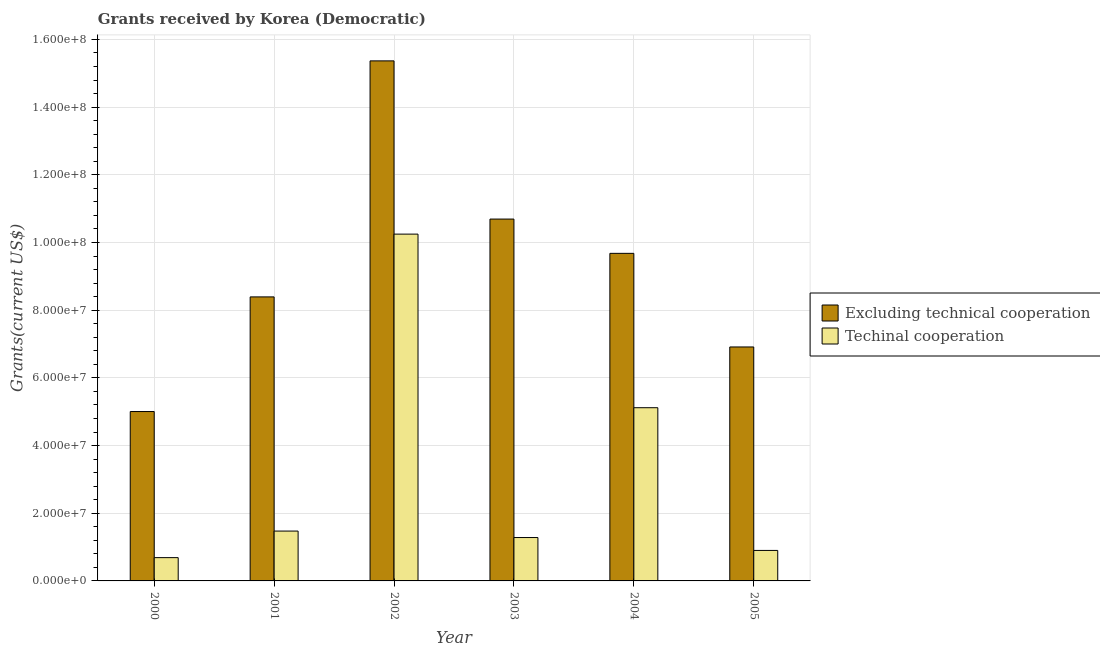Are the number of bars per tick equal to the number of legend labels?
Provide a short and direct response. Yes. Are the number of bars on each tick of the X-axis equal?
Provide a succinct answer. Yes. How many bars are there on the 3rd tick from the right?
Offer a very short reply. 2. What is the label of the 1st group of bars from the left?
Give a very brief answer. 2000. What is the amount of grants received(including technical cooperation) in 2001?
Offer a terse response. 1.47e+07. Across all years, what is the maximum amount of grants received(excluding technical cooperation)?
Your response must be concise. 1.54e+08. Across all years, what is the minimum amount of grants received(excluding technical cooperation)?
Give a very brief answer. 5.00e+07. In which year was the amount of grants received(including technical cooperation) minimum?
Keep it short and to the point. 2000. What is the total amount of grants received(excluding technical cooperation) in the graph?
Your answer should be compact. 5.60e+08. What is the difference between the amount of grants received(excluding technical cooperation) in 2004 and that in 2005?
Provide a short and direct response. 2.77e+07. What is the difference between the amount of grants received(including technical cooperation) in 2005 and the amount of grants received(excluding technical cooperation) in 2000?
Offer a terse response. 2.13e+06. What is the average amount of grants received(including technical cooperation) per year?
Provide a short and direct response. 3.28e+07. In the year 2001, what is the difference between the amount of grants received(excluding technical cooperation) and amount of grants received(including technical cooperation)?
Ensure brevity in your answer.  0. What is the ratio of the amount of grants received(including technical cooperation) in 2002 to that in 2003?
Make the answer very short. 7.99. Is the amount of grants received(including technical cooperation) in 2004 less than that in 2005?
Your answer should be very brief. No. What is the difference between the highest and the second highest amount of grants received(excluding technical cooperation)?
Your answer should be very brief. 4.67e+07. What is the difference between the highest and the lowest amount of grants received(excluding technical cooperation)?
Give a very brief answer. 1.04e+08. Is the sum of the amount of grants received(including technical cooperation) in 2000 and 2003 greater than the maximum amount of grants received(excluding technical cooperation) across all years?
Your answer should be compact. No. What does the 1st bar from the left in 2003 represents?
Provide a short and direct response. Excluding technical cooperation. What does the 2nd bar from the right in 2002 represents?
Offer a terse response. Excluding technical cooperation. How many bars are there?
Offer a terse response. 12. What is the difference between two consecutive major ticks on the Y-axis?
Your answer should be compact. 2.00e+07. Are the values on the major ticks of Y-axis written in scientific E-notation?
Offer a terse response. Yes. Does the graph contain grids?
Your answer should be very brief. Yes. Where does the legend appear in the graph?
Offer a terse response. Center right. How many legend labels are there?
Provide a succinct answer. 2. What is the title of the graph?
Make the answer very short. Grants received by Korea (Democratic). What is the label or title of the X-axis?
Make the answer very short. Year. What is the label or title of the Y-axis?
Give a very brief answer. Grants(current US$). What is the Grants(current US$) of Excluding technical cooperation in 2000?
Ensure brevity in your answer.  5.00e+07. What is the Grants(current US$) in Techinal cooperation in 2000?
Provide a short and direct response. 6.88e+06. What is the Grants(current US$) of Excluding technical cooperation in 2001?
Make the answer very short. 8.39e+07. What is the Grants(current US$) of Techinal cooperation in 2001?
Your answer should be very brief. 1.47e+07. What is the Grants(current US$) of Excluding technical cooperation in 2002?
Offer a terse response. 1.54e+08. What is the Grants(current US$) of Techinal cooperation in 2002?
Make the answer very short. 1.02e+08. What is the Grants(current US$) of Excluding technical cooperation in 2003?
Make the answer very short. 1.07e+08. What is the Grants(current US$) of Techinal cooperation in 2003?
Give a very brief answer. 1.28e+07. What is the Grants(current US$) of Excluding technical cooperation in 2004?
Your answer should be compact. 9.68e+07. What is the Grants(current US$) of Techinal cooperation in 2004?
Give a very brief answer. 5.12e+07. What is the Grants(current US$) in Excluding technical cooperation in 2005?
Your answer should be compact. 6.91e+07. What is the Grants(current US$) in Techinal cooperation in 2005?
Provide a short and direct response. 9.01e+06. Across all years, what is the maximum Grants(current US$) in Excluding technical cooperation?
Provide a succinct answer. 1.54e+08. Across all years, what is the maximum Grants(current US$) in Techinal cooperation?
Make the answer very short. 1.02e+08. Across all years, what is the minimum Grants(current US$) of Excluding technical cooperation?
Your answer should be very brief. 5.00e+07. Across all years, what is the minimum Grants(current US$) of Techinal cooperation?
Your response must be concise. 6.88e+06. What is the total Grants(current US$) of Excluding technical cooperation in the graph?
Offer a terse response. 5.60e+08. What is the total Grants(current US$) in Techinal cooperation in the graph?
Your response must be concise. 1.97e+08. What is the difference between the Grants(current US$) in Excluding technical cooperation in 2000 and that in 2001?
Ensure brevity in your answer.  -3.39e+07. What is the difference between the Grants(current US$) of Techinal cooperation in 2000 and that in 2001?
Your answer should be compact. -7.85e+06. What is the difference between the Grants(current US$) of Excluding technical cooperation in 2000 and that in 2002?
Ensure brevity in your answer.  -1.04e+08. What is the difference between the Grants(current US$) of Techinal cooperation in 2000 and that in 2002?
Ensure brevity in your answer.  -9.56e+07. What is the difference between the Grants(current US$) in Excluding technical cooperation in 2000 and that in 2003?
Your answer should be compact. -5.69e+07. What is the difference between the Grants(current US$) of Techinal cooperation in 2000 and that in 2003?
Provide a succinct answer. -5.94e+06. What is the difference between the Grants(current US$) of Excluding technical cooperation in 2000 and that in 2004?
Your answer should be compact. -4.67e+07. What is the difference between the Grants(current US$) in Techinal cooperation in 2000 and that in 2004?
Offer a very short reply. -4.43e+07. What is the difference between the Grants(current US$) in Excluding technical cooperation in 2000 and that in 2005?
Your response must be concise. -1.91e+07. What is the difference between the Grants(current US$) in Techinal cooperation in 2000 and that in 2005?
Ensure brevity in your answer.  -2.13e+06. What is the difference between the Grants(current US$) of Excluding technical cooperation in 2001 and that in 2002?
Make the answer very short. -6.97e+07. What is the difference between the Grants(current US$) in Techinal cooperation in 2001 and that in 2002?
Keep it short and to the point. -8.77e+07. What is the difference between the Grants(current US$) of Excluding technical cooperation in 2001 and that in 2003?
Give a very brief answer. -2.30e+07. What is the difference between the Grants(current US$) in Techinal cooperation in 2001 and that in 2003?
Make the answer very short. 1.91e+06. What is the difference between the Grants(current US$) of Excluding technical cooperation in 2001 and that in 2004?
Your answer should be very brief. -1.29e+07. What is the difference between the Grants(current US$) in Techinal cooperation in 2001 and that in 2004?
Give a very brief answer. -3.64e+07. What is the difference between the Grants(current US$) in Excluding technical cooperation in 2001 and that in 2005?
Your answer should be compact. 1.48e+07. What is the difference between the Grants(current US$) in Techinal cooperation in 2001 and that in 2005?
Ensure brevity in your answer.  5.72e+06. What is the difference between the Grants(current US$) of Excluding technical cooperation in 2002 and that in 2003?
Your answer should be very brief. 4.67e+07. What is the difference between the Grants(current US$) in Techinal cooperation in 2002 and that in 2003?
Offer a terse response. 8.96e+07. What is the difference between the Grants(current US$) of Excluding technical cooperation in 2002 and that in 2004?
Provide a short and direct response. 5.69e+07. What is the difference between the Grants(current US$) of Techinal cooperation in 2002 and that in 2004?
Make the answer very short. 5.13e+07. What is the difference between the Grants(current US$) of Excluding technical cooperation in 2002 and that in 2005?
Your answer should be compact. 8.45e+07. What is the difference between the Grants(current US$) of Techinal cooperation in 2002 and that in 2005?
Provide a succinct answer. 9.35e+07. What is the difference between the Grants(current US$) in Excluding technical cooperation in 2003 and that in 2004?
Offer a very short reply. 1.01e+07. What is the difference between the Grants(current US$) of Techinal cooperation in 2003 and that in 2004?
Give a very brief answer. -3.84e+07. What is the difference between the Grants(current US$) of Excluding technical cooperation in 2003 and that in 2005?
Keep it short and to the point. 3.78e+07. What is the difference between the Grants(current US$) of Techinal cooperation in 2003 and that in 2005?
Provide a short and direct response. 3.81e+06. What is the difference between the Grants(current US$) in Excluding technical cooperation in 2004 and that in 2005?
Ensure brevity in your answer.  2.77e+07. What is the difference between the Grants(current US$) of Techinal cooperation in 2004 and that in 2005?
Make the answer very short. 4.22e+07. What is the difference between the Grants(current US$) in Excluding technical cooperation in 2000 and the Grants(current US$) in Techinal cooperation in 2001?
Provide a succinct answer. 3.53e+07. What is the difference between the Grants(current US$) in Excluding technical cooperation in 2000 and the Grants(current US$) in Techinal cooperation in 2002?
Offer a very short reply. -5.24e+07. What is the difference between the Grants(current US$) of Excluding technical cooperation in 2000 and the Grants(current US$) of Techinal cooperation in 2003?
Your answer should be compact. 3.72e+07. What is the difference between the Grants(current US$) of Excluding technical cooperation in 2000 and the Grants(current US$) of Techinal cooperation in 2004?
Keep it short and to the point. -1.13e+06. What is the difference between the Grants(current US$) of Excluding technical cooperation in 2000 and the Grants(current US$) of Techinal cooperation in 2005?
Provide a short and direct response. 4.10e+07. What is the difference between the Grants(current US$) in Excluding technical cooperation in 2001 and the Grants(current US$) in Techinal cooperation in 2002?
Your answer should be very brief. -1.86e+07. What is the difference between the Grants(current US$) of Excluding technical cooperation in 2001 and the Grants(current US$) of Techinal cooperation in 2003?
Keep it short and to the point. 7.11e+07. What is the difference between the Grants(current US$) in Excluding technical cooperation in 2001 and the Grants(current US$) in Techinal cooperation in 2004?
Your answer should be very brief. 3.27e+07. What is the difference between the Grants(current US$) of Excluding technical cooperation in 2001 and the Grants(current US$) of Techinal cooperation in 2005?
Ensure brevity in your answer.  7.49e+07. What is the difference between the Grants(current US$) of Excluding technical cooperation in 2002 and the Grants(current US$) of Techinal cooperation in 2003?
Your answer should be very brief. 1.41e+08. What is the difference between the Grants(current US$) in Excluding technical cooperation in 2002 and the Grants(current US$) in Techinal cooperation in 2004?
Give a very brief answer. 1.02e+08. What is the difference between the Grants(current US$) of Excluding technical cooperation in 2002 and the Grants(current US$) of Techinal cooperation in 2005?
Offer a terse response. 1.45e+08. What is the difference between the Grants(current US$) in Excluding technical cooperation in 2003 and the Grants(current US$) in Techinal cooperation in 2004?
Ensure brevity in your answer.  5.57e+07. What is the difference between the Grants(current US$) of Excluding technical cooperation in 2003 and the Grants(current US$) of Techinal cooperation in 2005?
Provide a succinct answer. 9.79e+07. What is the difference between the Grants(current US$) of Excluding technical cooperation in 2004 and the Grants(current US$) of Techinal cooperation in 2005?
Offer a terse response. 8.78e+07. What is the average Grants(current US$) of Excluding technical cooperation per year?
Provide a short and direct response. 9.34e+07. What is the average Grants(current US$) of Techinal cooperation per year?
Offer a very short reply. 3.28e+07. In the year 2000, what is the difference between the Grants(current US$) in Excluding technical cooperation and Grants(current US$) in Techinal cooperation?
Give a very brief answer. 4.32e+07. In the year 2001, what is the difference between the Grants(current US$) of Excluding technical cooperation and Grants(current US$) of Techinal cooperation?
Provide a succinct answer. 6.92e+07. In the year 2002, what is the difference between the Grants(current US$) of Excluding technical cooperation and Grants(current US$) of Techinal cooperation?
Your response must be concise. 5.12e+07. In the year 2003, what is the difference between the Grants(current US$) of Excluding technical cooperation and Grants(current US$) of Techinal cooperation?
Give a very brief answer. 9.41e+07. In the year 2004, what is the difference between the Grants(current US$) of Excluding technical cooperation and Grants(current US$) of Techinal cooperation?
Your answer should be very brief. 4.56e+07. In the year 2005, what is the difference between the Grants(current US$) of Excluding technical cooperation and Grants(current US$) of Techinal cooperation?
Keep it short and to the point. 6.01e+07. What is the ratio of the Grants(current US$) of Excluding technical cooperation in 2000 to that in 2001?
Give a very brief answer. 0.6. What is the ratio of the Grants(current US$) in Techinal cooperation in 2000 to that in 2001?
Keep it short and to the point. 0.47. What is the ratio of the Grants(current US$) of Excluding technical cooperation in 2000 to that in 2002?
Provide a short and direct response. 0.33. What is the ratio of the Grants(current US$) in Techinal cooperation in 2000 to that in 2002?
Make the answer very short. 0.07. What is the ratio of the Grants(current US$) of Excluding technical cooperation in 2000 to that in 2003?
Provide a short and direct response. 0.47. What is the ratio of the Grants(current US$) of Techinal cooperation in 2000 to that in 2003?
Keep it short and to the point. 0.54. What is the ratio of the Grants(current US$) of Excluding technical cooperation in 2000 to that in 2004?
Make the answer very short. 0.52. What is the ratio of the Grants(current US$) of Techinal cooperation in 2000 to that in 2004?
Your response must be concise. 0.13. What is the ratio of the Grants(current US$) of Excluding technical cooperation in 2000 to that in 2005?
Ensure brevity in your answer.  0.72. What is the ratio of the Grants(current US$) in Techinal cooperation in 2000 to that in 2005?
Your answer should be compact. 0.76. What is the ratio of the Grants(current US$) of Excluding technical cooperation in 2001 to that in 2002?
Ensure brevity in your answer.  0.55. What is the ratio of the Grants(current US$) of Techinal cooperation in 2001 to that in 2002?
Your answer should be very brief. 0.14. What is the ratio of the Grants(current US$) in Excluding technical cooperation in 2001 to that in 2003?
Keep it short and to the point. 0.78. What is the ratio of the Grants(current US$) of Techinal cooperation in 2001 to that in 2003?
Make the answer very short. 1.15. What is the ratio of the Grants(current US$) of Excluding technical cooperation in 2001 to that in 2004?
Provide a short and direct response. 0.87. What is the ratio of the Grants(current US$) in Techinal cooperation in 2001 to that in 2004?
Your answer should be very brief. 0.29. What is the ratio of the Grants(current US$) of Excluding technical cooperation in 2001 to that in 2005?
Your answer should be very brief. 1.21. What is the ratio of the Grants(current US$) of Techinal cooperation in 2001 to that in 2005?
Provide a short and direct response. 1.63. What is the ratio of the Grants(current US$) of Excluding technical cooperation in 2002 to that in 2003?
Give a very brief answer. 1.44. What is the ratio of the Grants(current US$) in Techinal cooperation in 2002 to that in 2003?
Your answer should be very brief. 7.99. What is the ratio of the Grants(current US$) of Excluding technical cooperation in 2002 to that in 2004?
Make the answer very short. 1.59. What is the ratio of the Grants(current US$) of Techinal cooperation in 2002 to that in 2004?
Offer a terse response. 2. What is the ratio of the Grants(current US$) of Excluding technical cooperation in 2002 to that in 2005?
Give a very brief answer. 2.22. What is the ratio of the Grants(current US$) in Techinal cooperation in 2002 to that in 2005?
Make the answer very short. 11.37. What is the ratio of the Grants(current US$) in Excluding technical cooperation in 2003 to that in 2004?
Your response must be concise. 1.1. What is the ratio of the Grants(current US$) of Techinal cooperation in 2003 to that in 2004?
Provide a short and direct response. 0.25. What is the ratio of the Grants(current US$) in Excluding technical cooperation in 2003 to that in 2005?
Keep it short and to the point. 1.55. What is the ratio of the Grants(current US$) of Techinal cooperation in 2003 to that in 2005?
Offer a very short reply. 1.42. What is the ratio of the Grants(current US$) of Excluding technical cooperation in 2004 to that in 2005?
Keep it short and to the point. 1.4. What is the ratio of the Grants(current US$) of Techinal cooperation in 2004 to that in 2005?
Your answer should be compact. 5.68. What is the difference between the highest and the second highest Grants(current US$) of Excluding technical cooperation?
Ensure brevity in your answer.  4.67e+07. What is the difference between the highest and the second highest Grants(current US$) in Techinal cooperation?
Make the answer very short. 5.13e+07. What is the difference between the highest and the lowest Grants(current US$) in Excluding technical cooperation?
Keep it short and to the point. 1.04e+08. What is the difference between the highest and the lowest Grants(current US$) of Techinal cooperation?
Offer a terse response. 9.56e+07. 